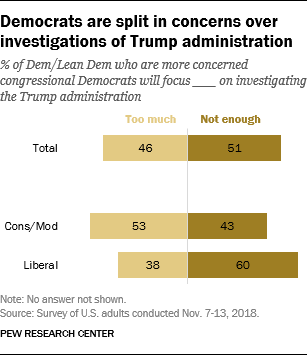Draw attention to some important aspects in this diagram. Out of the total surveyed, 0.46% hold the opinion that the service is too much. The sum of all the bars above 50 is 164. 